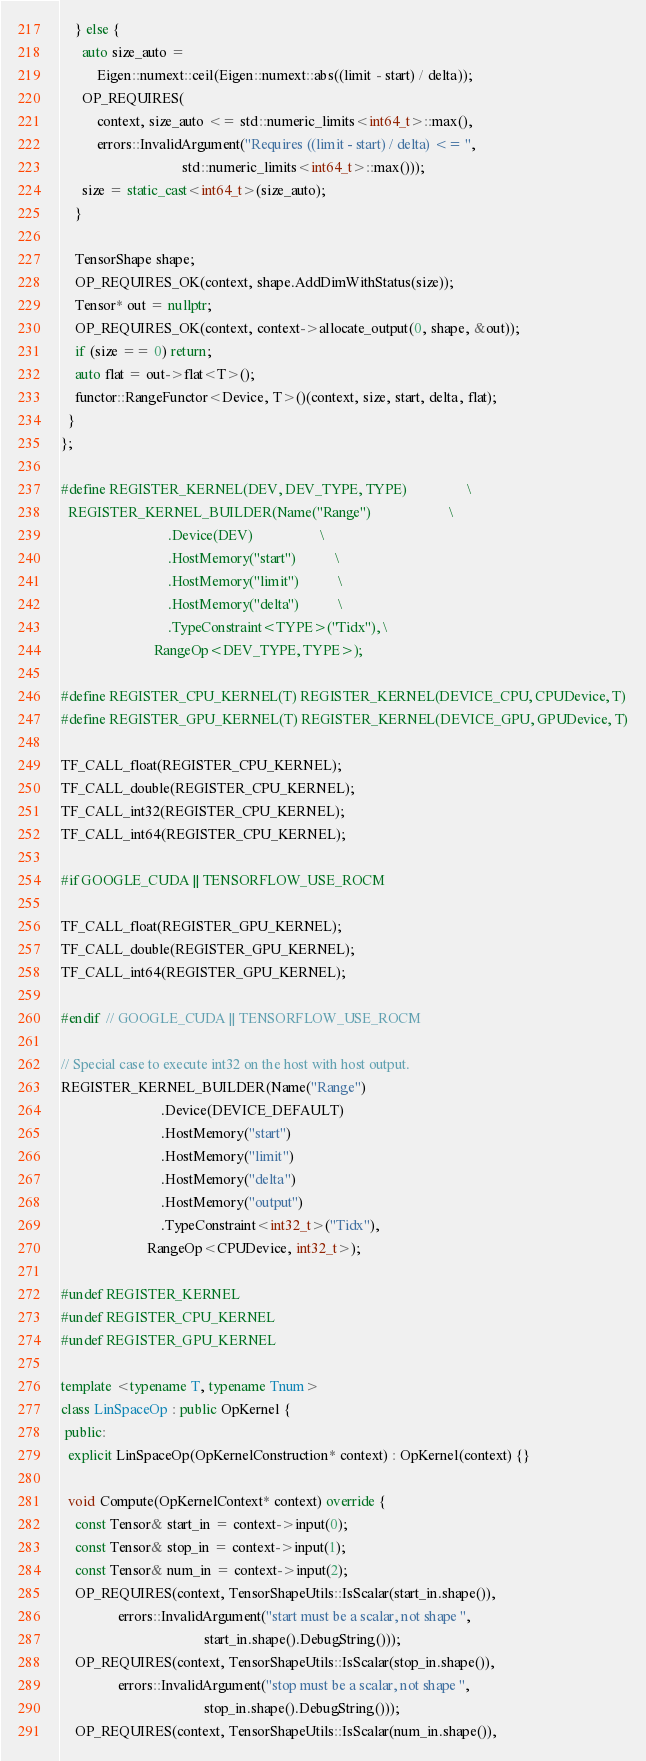Convert code to text. <code><loc_0><loc_0><loc_500><loc_500><_C++_>    } else {
      auto size_auto =
          Eigen::numext::ceil(Eigen::numext::abs((limit - start) / delta));
      OP_REQUIRES(
          context, size_auto <= std::numeric_limits<int64_t>::max(),
          errors::InvalidArgument("Requires ((limit - start) / delta) <= ",
                                  std::numeric_limits<int64_t>::max()));
      size = static_cast<int64_t>(size_auto);
    }

    TensorShape shape;
    OP_REQUIRES_OK(context, shape.AddDimWithStatus(size));
    Tensor* out = nullptr;
    OP_REQUIRES_OK(context, context->allocate_output(0, shape, &out));
    if (size == 0) return;
    auto flat = out->flat<T>();
    functor::RangeFunctor<Device, T>()(context, size, start, delta, flat);
  }
};

#define REGISTER_KERNEL(DEV, DEV_TYPE, TYPE)                 \
  REGISTER_KERNEL_BUILDER(Name("Range")                      \
                              .Device(DEV)                   \
                              .HostMemory("start")           \
                              .HostMemory("limit")           \
                              .HostMemory("delta")           \
                              .TypeConstraint<TYPE>("Tidx"), \
                          RangeOp<DEV_TYPE, TYPE>);

#define REGISTER_CPU_KERNEL(T) REGISTER_KERNEL(DEVICE_CPU, CPUDevice, T)
#define REGISTER_GPU_KERNEL(T) REGISTER_KERNEL(DEVICE_GPU, GPUDevice, T)

TF_CALL_float(REGISTER_CPU_KERNEL);
TF_CALL_double(REGISTER_CPU_KERNEL);
TF_CALL_int32(REGISTER_CPU_KERNEL);
TF_CALL_int64(REGISTER_CPU_KERNEL);

#if GOOGLE_CUDA || TENSORFLOW_USE_ROCM

TF_CALL_float(REGISTER_GPU_KERNEL);
TF_CALL_double(REGISTER_GPU_KERNEL);
TF_CALL_int64(REGISTER_GPU_KERNEL);

#endif  // GOOGLE_CUDA || TENSORFLOW_USE_ROCM

// Special case to execute int32 on the host with host output.
REGISTER_KERNEL_BUILDER(Name("Range")
                            .Device(DEVICE_DEFAULT)
                            .HostMemory("start")
                            .HostMemory("limit")
                            .HostMemory("delta")
                            .HostMemory("output")
                            .TypeConstraint<int32_t>("Tidx"),
                        RangeOp<CPUDevice, int32_t>);

#undef REGISTER_KERNEL
#undef REGISTER_CPU_KERNEL
#undef REGISTER_GPU_KERNEL

template <typename T, typename Tnum>
class LinSpaceOp : public OpKernel {
 public:
  explicit LinSpaceOp(OpKernelConstruction* context) : OpKernel(context) {}

  void Compute(OpKernelContext* context) override {
    const Tensor& start_in = context->input(0);
    const Tensor& stop_in = context->input(1);
    const Tensor& num_in = context->input(2);
    OP_REQUIRES(context, TensorShapeUtils::IsScalar(start_in.shape()),
                errors::InvalidArgument("start must be a scalar, not shape ",
                                        start_in.shape().DebugString()));
    OP_REQUIRES(context, TensorShapeUtils::IsScalar(stop_in.shape()),
                errors::InvalidArgument("stop must be a scalar, not shape ",
                                        stop_in.shape().DebugString()));
    OP_REQUIRES(context, TensorShapeUtils::IsScalar(num_in.shape()),</code> 